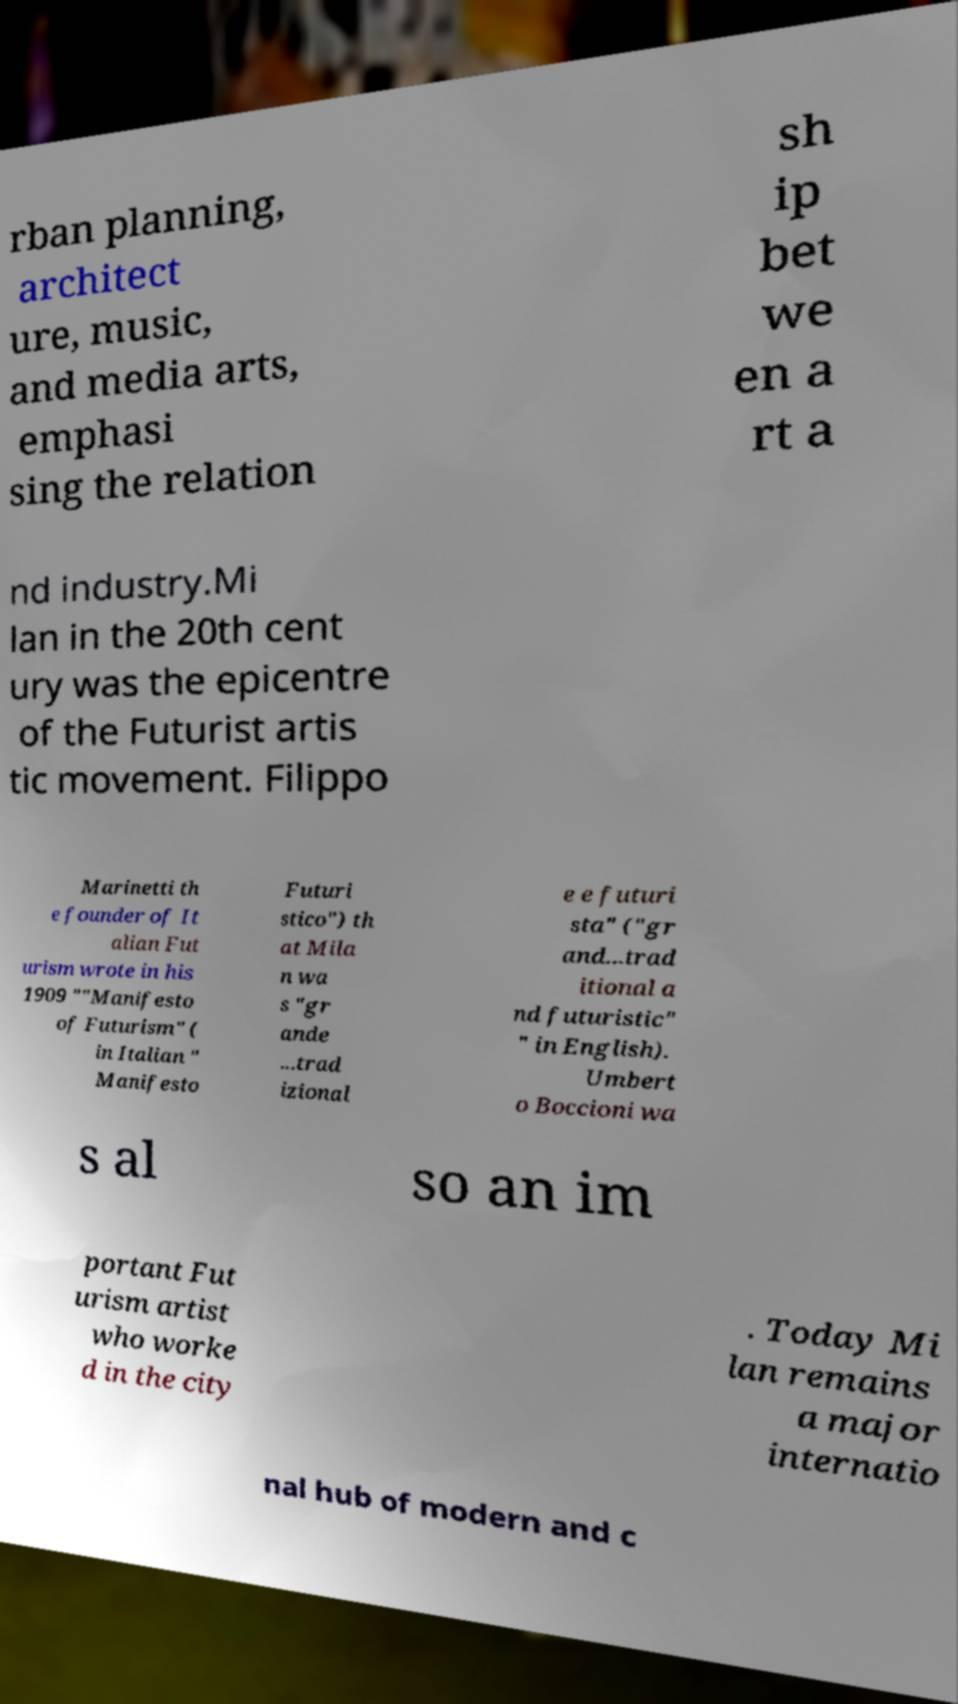Please identify and transcribe the text found in this image. rban planning, architect ure, music, and media arts, emphasi sing the relation sh ip bet we en a rt a nd industry.Mi lan in the 20th cent ury was the epicentre of the Futurist artis tic movement. Filippo Marinetti th e founder of It alian Fut urism wrote in his 1909 ""Manifesto of Futurism" ( in Italian " Manifesto Futuri stico") th at Mila n wa s "gr ande ...trad izional e e futuri sta" ("gr and...trad itional a nd futuristic" " in English). Umbert o Boccioni wa s al so an im portant Fut urism artist who worke d in the city . Today Mi lan remains a major internatio nal hub of modern and c 